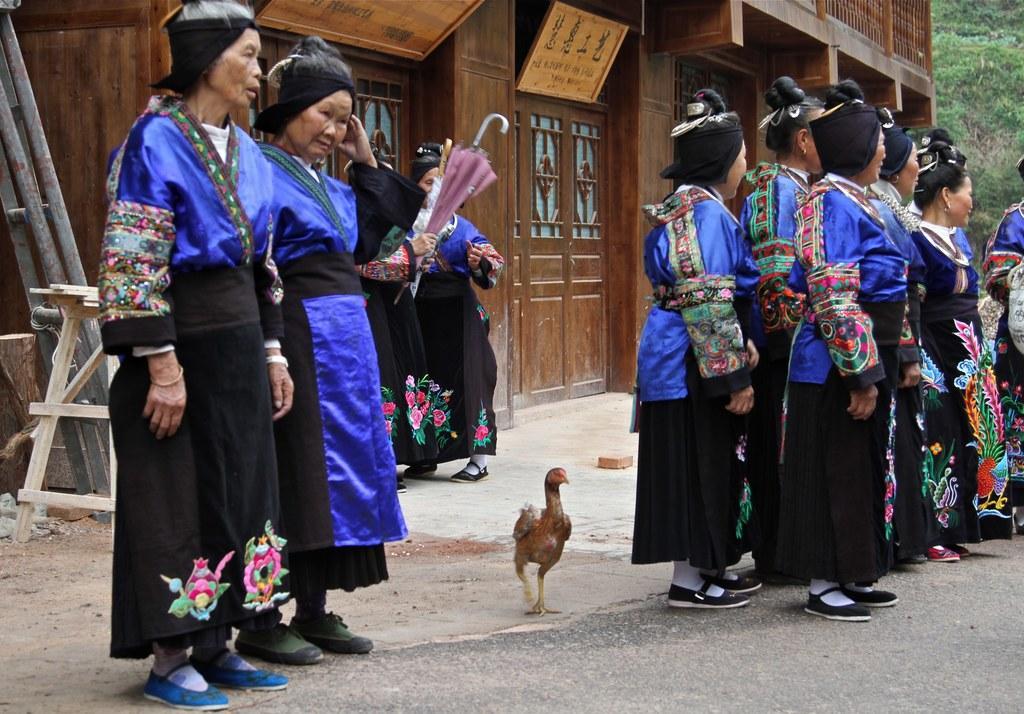Please provide a concise description of this image. In this image there are group of people standing, and one woman is holding and umbrella. In the background there is a house and some boards, on the boards there is text. On the left side there is a stool and some poles, on the right side there are some trees and at the bottom there is a road and in the center there is one hen. 